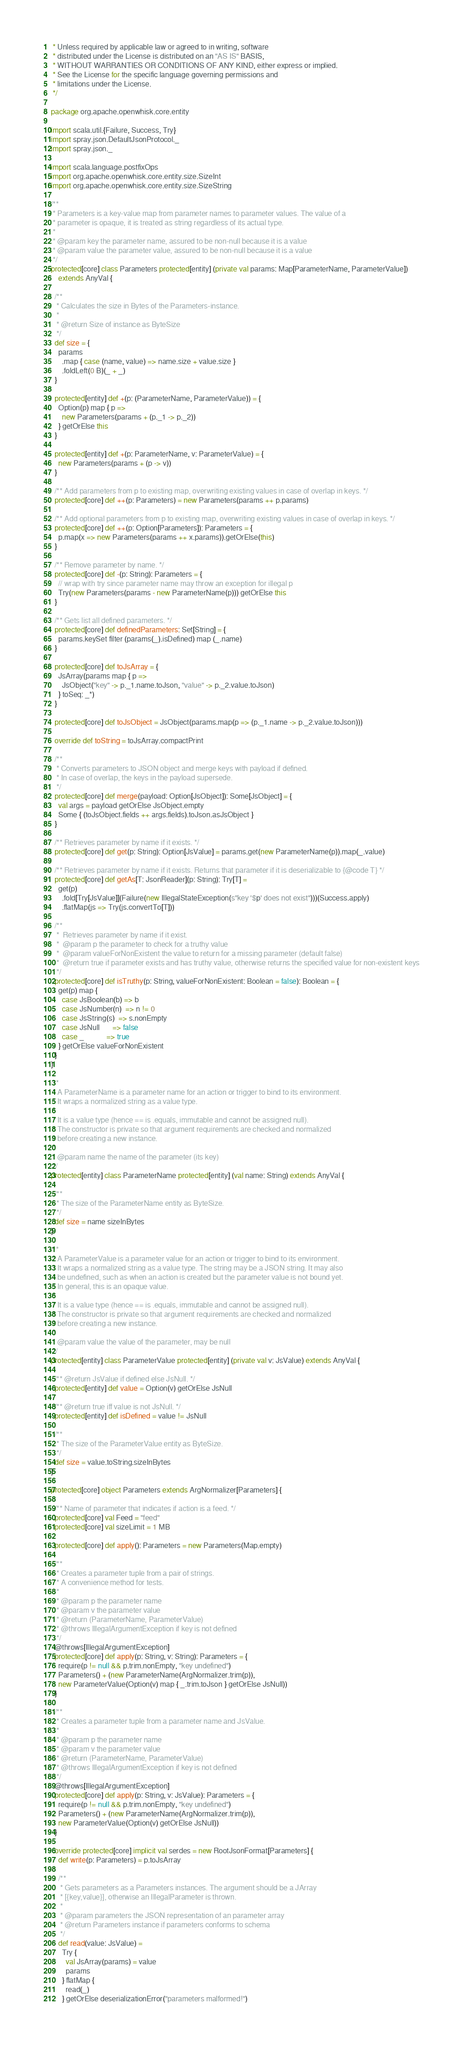<code> <loc_0><loc_0><loc_500><loc_500><_Scala_> * Unless required by applicable law or agreed to in writing, software
 * distributed under the License is distributed on an "AS IS" BASIS,
 * WITHOUT WARRANTIES OR CONDITIONS OF ANY KIND, either express or implied.
 * See the License for the specific language governing permissions and
 * limitations under the License.
 */

package org.apache.openwhisk.core.entity

import scala.util.{Failure, Success, Try}
import spray.json.DefaultJsonProtocol._
import spray.json._

import scala.language.postfixOps
import org.apache.openwhisk.core.entity.size.SizeInt
import org.apache.openwhisk.core.entity.size.SizeString

/**
 * Parameters is a key-value map from parameter names to parameter values. The value of a
 * parameter is opaque, it is treated as string regardless of its actual type.
 *
 * @param key the parameter name, assured to be non-null because it is a value
 * @param value the parameter value, assured to be non-null because it is a value
 */
protected[core] class Parameters protected[entity] (private val params: Map[ParameterName, ParameterValue])
    extends AnyVal {

  /**
   * Calculates the size in Bytes of the Parameters-instance.
   *
   * @return Size of instance as ByteSize
   */
  def size = {
    params
      .map { case (name, value) => name.size + value.size }
      .foldLeft(0 B)(_ + _)
  }

  protected[entity] def +(p: (ParameterName, ParameterValue)) = {
    Option(p) map { p =>
      new Parameters(params + (p._1 -> p._2))
    } getOrElse this
  }

  protected[entity] def +(p: ParameterName, v: ParameterValue) = {
    new Parameters(params + (p -> v))
  }

  /** Add parameters from p to existing map, overwriting existing values in case of overlap in keys. */
  protected[core] def ++(p: Parameters) = new Parameters(params ++ p.params)

  /** Add optional parameters from p to existing map, overwriting existing values in case of overlap in keys. */
  protected[core] def ++(p: Option[Parameters]): Parameters = {
    p.map(x => new Parameters(params ++ x.params)).getOrElse(this)
  }

  /** Remove parameter by name. */
  protected[core] def -(p: String): Parameters = {
    // wrap with try since parameter name may throw an exception for illegal p
    Try(new Parameters(params - new ParameterName(p))) getOrElse this
  }

  /** Gets list all defined parameters. */
  protected[core] def definedParameters: Set[String] = {
    params.keySet filter (params(_).isDefined) map (_.name)
  }

  protected[core] def toJsArray = {
    JsArray(params map { p =>
      JsObject("key" -> p._1.name.toJson, "value" -> p._2.value.toJson)
    } toSeq: _*)
  }

  protected[core] def toJsObject = JsObject(params.map(p => (p._1.name -> p._2.value.toJson)))

  override def toString = toJsArray.compactPrint

  /**
   * Converts parameters to JSON object and merge keys with payload if defined.
   * In case of overlap, the keys in the payload supersede.
   */
  protected[core] def merge(payload: Option[JsObject]): Some[JsObject] = {
    val args = payload getOrElse JsObject.empty
    Some { (toJsObject.fields ++ args.fields).toJson.asJsObject }
  }

  /** Retrieves parameter by name if it exists. */
  protected[core] def get(p: String): Option[JsValue] = params.get(new ParameterName(p)).map(_.value)

  /** Retrieves parameter by name if it exists. Returns that parameter if it is deserializable to {@code T} */
  protected[core] def getAs[T: JsonReader](p: String): Try[T] =
    get(p)
      .fold[Try[JsValue]](Failure(new IllegalStateException(s"key '$p' does not exist")))(Success.apply)
      .flatMap(js => Try(js.convertTo[T]))

  /**
   *  Retrieves parameter by name if it exist.
   *  @param p the parameter to check for a truthy value
   *  @param valueForNonExistent the value to return for a missing parameter (default false)
   *  @return true if parameter exists and has truthy value, otherwise returns the specified value for non-existent keys
   */
  protected[core] def isTruthy(p: String, valueForNonExistent: Boolean = false): Boolean = {
    get(p) map {
      case JsBoolean(b) => b
      case JsNumber(n)  => n != 0
      case JsString(s)  => s.nonEmpty
      case JsNull       => false
      case _            => true
    } getOrElse valueForNonExistent
  }
}

/**
 * A ParameterName is a parameter name for an action or trigger to bind to its environment.
 * It wraps a normalized string as a value type.
 *
 * It is a value type (hence == is .equals, immutable and cannot be assigned null).
 * The constructor is private so that argument requirements are checked and normalized
 * before creating a new instance.
 *
 * @param name the name of the parameter (its key)
 */
protected[entity] class ParameterName protected[entity] (val name: String) extends AnyVal {

  /**
   * The size of the ParameterName entity as ByteSize.
   */
  def size = name sizeInBytes
}

/**
 * A ParameterValue is a parameter value for an action or trigger to bind to its environment.
 * It wraps a normalized string as a value type. The string may be a JSON string. It may also
 * be undefined, such as when an action is created but the parameter value is not bound yet.
 * In general, this is an opaque value.
 *
 * It is a value type (hence == is .equals, immutable and cannot be assigned null).
 * The constructor is private so that argument requirements are checked and normalized
 * before creating a new instance.
 *
 * @param value the value of the parameter, may be null
 */
protected[entity] class ParameterValue protected[entity] (private val v: JsValue) extends AnyVal {

  /** @return JsValue if defined else JsNull. */
  protected[entity] def value = Option(v) getOrElse JsNull

  /** @return true iff value is not JsNull. */
  protected[entity] def isDefined = value != JsNull

  /**
   * The size of the ParameterValue entity as ByteSize.
   */
  def size = value.toString.sizeInBytes
}

protected[core] object Parameters extends ArgNormalizer[Parameters] {

  /** Name of parameter that indicates if action is a feed. */
  protected[core] val Feed = "feed"
  protected[core] val sizeLimit = 1 MB

  protected[core] def apply(): Parameters = new Parameters(Map.empty)

  /**
   * Creates a parameter tuple from a pair of strings.
   * A convenience method for tests.
   *
   * @param p the parameter name
   * @param v the parameter value
   * @return (ParameterName, ParameterValue)
   * @throws IllegalArgumentException if key is not defined
   */
  @throws[IllegalArgumentException]
  protected[core] def apply(p: String, v: String): Parameters = {
    require(p != null && p.trim.nonEmpty, "key undefined")
    Parameters() + (new ParameterName(ArgNormalizer.trim(p)),
    new ParameterValue(Option(v) map { _.trim.toJson } getOrElse JsNull))
  }

  /**
   * Creates a parameter tuple from a parameter name and JsValue.
   *
   * @param p the parameter name
   * @param v the parameter value
   * @return (ParameterName, ParameterValue)
   * @throws IllegalArgumentException if key is not defined
   */
  @throws[IllegalArgumentException]
  protected[core] def apply(p: String, v: JsValue): Parameters = {
    require(p != null && p.trim.nonEmpty, "key undefined")
    Parameters() + (new ParameterName(ArgNormalizer.trim(p)),
    new ParameterValue(Option(v) getOrElse JsNull))
  }

  override protected[core] implicit val serdes = new RootJsonFormat[Parameters] {
    def write(p: Parameters) = p.toJsArray

    /**
     * Gets parameters as a Parameters instances. The argument should be a JArray
     * [{key,value}], otherwise an IllegalParameter is thrown.
     *
     * @param parameters the JSON representation of an parameter array
     * @return Parameters instance if parameters conforms to schema
     */
    def read(value: JsValue) =
      Try {
        val JsArray(params) = value
        params
      } flatMap {
        read(_)
      } getOrElse deserializationError("parameters malformed!")
</code> 